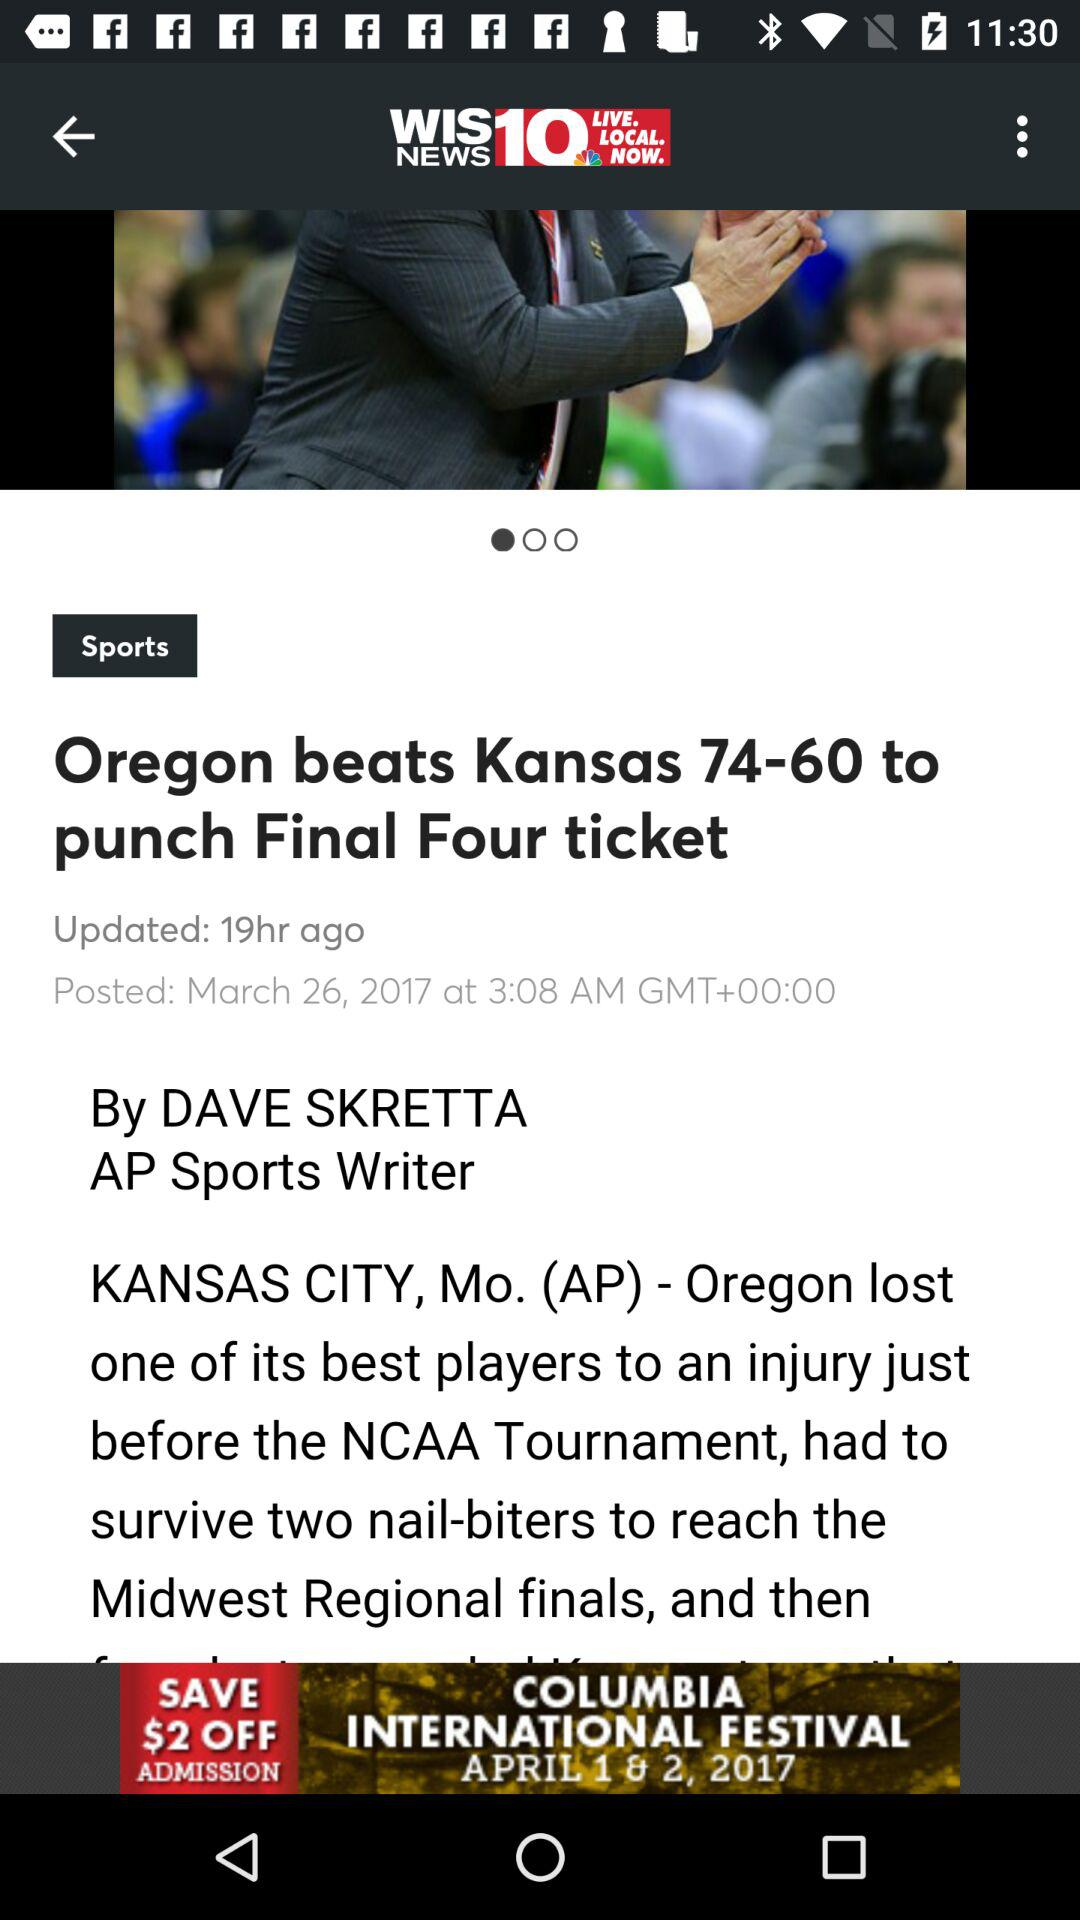Who is the author of the news? The author of the news is Dave Skretta. 